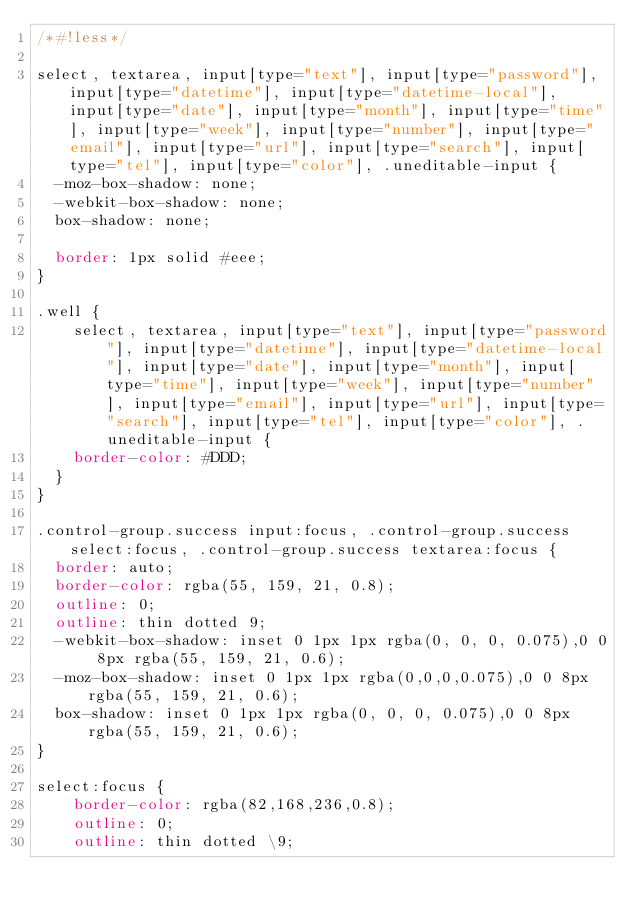Convert code to text. <code><loc_0><loc_0><loc_500><loc_500><_CSS_>/*#!less*/

select, textarea, input[type="text"], input[type="password"], input[type="datetime"], input[type="datetime-local"], input[type="date"], input[type="month"], input[type="time"], input[type="week"], input[type="number"], input[type="email"], input[type="url"], input[type="search"], input[type="tel"], input[type="color"], .uneditable-input {
	-moz-box-shadow: none;
	-webkit-box-shadow: none;
	box-shadow: none;

	border: 1px solid #eee;
}

.well {
    select, textarea, input[type="text"], input[type="password"], input[type="datetime"], input[type="datetime-local"], input[type="date"], input[type="month"], input[type="time"], input[type="week"], input[type="number"], input[type="email"], input[type="url"], input[type="search"], input[type="tel"], input[type="color"], .uneditable-input {
		border-color: #DDD;
	}
}

.control-group.success input:focus, .control-group.success select:focus, .control-group.success textarea:focus {
	border: auto;
	border-color: rgba(55, 159, 21, 0.8);
	outline: 0;
	outline: thin dotted 9;
	-webkit-box-shadow: inset 0 1px 1px rgba(0, 0, 0, 0.075),0 0 8px rgba(55, 159, 21, 0.6);
	-moz-box-shadow: inset 0 1px 1px rgba(0,0,0,0.075),0 0 8px rgba(55, 159, 21, 0.6);
	box-shadow: inset 0 1px 1px rgba(0, 0, 0, 0.075),0 0 8px rgba(55, 159, 21, 0.6);
}

select:focus {
    border-color: rgba(82,168,236,0.8);
    outline: 0;
    outline: thin dotted \9;</code> 